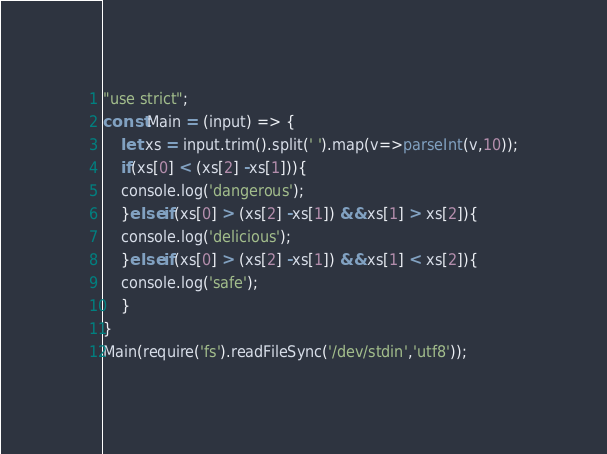<code> <loc_0><loc_0><loc_500><loc_500><_JavaScript_>"use strict";
const Main = (input) => {
	let xs = input.trim().split(' ').map(v=>parseInt(v,10));
  	if(xs[0] < (xs[2] -xs[1])){
    console.log('dangerous');
    }else if(xs[0] > (xs[2] -xs[1]) && xs[1] > xs[2]){
    console.log('delicious');
    }else if(xs[0] > (xs[2] -xs[1]) && xs[1] < xs[2]){
    console.log('safe');
    }
}
Main(require('fs').readFileSync('/dev/stdin','utf8'));</code> 